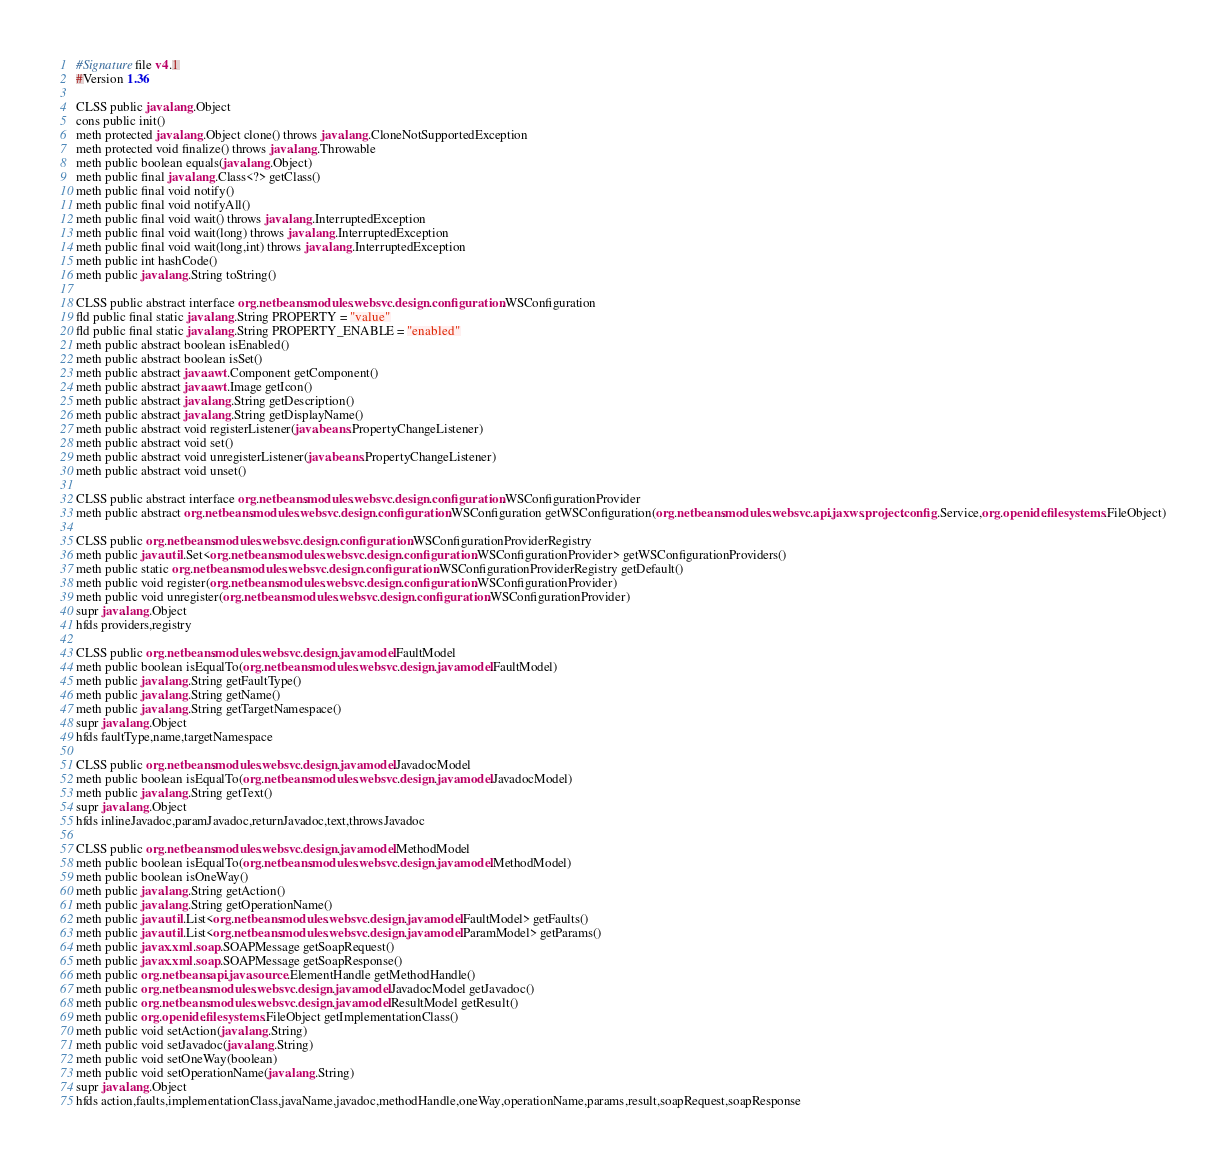Convert code to text. <code><loc_0><loc_0><loc_500><loc_500><_SML_>#Signature file v4.1
#Version 1.36

CLSS public java.lang.Object
cons public init()
meth protected java.lang.Object clone() throws java.lang.CloneNotSupportedException
meth protected void finalize() throws java.lang.Throwable
meth public boolean equals(java.lang.Object)
meth public final java.lang.Class<?> getClass()
meth public final void notify()
meth public final void notifyAll()
meth public final void wait() throws java.lang.InterruptedException
meth public final void wait(long) throws java.lang.InterruptedException
meth public final void wait(long,int) throws java.lang.InterruptedException
meth public int hashCode()
meth public java.lang.String toString()

CLSS public abstract interface org.netbeans.modules.websvc.design.configuration.WSConfiguration
fld public final static java.lang.String PROPERTY = "value"
fld public final static java.lang.String PROPERTY_ENABLE = "enabled"
meth public abstract boolean isEnabled()
meth public abstract boolean isSet()
meth public abstract java.awt.Component getComponent()
meth public abstract java.awt.Image getIcon()
meth public abstract java.lang.String getDescription()
meth public abstract java.lang.String getDisplayName()
meth public abstract void registerListener(java.beans.PropertyChangeListener)
meth public abstract void set()
meth public abstract void unregisterListener(java.beans.PropertyChangeListener)
meth public abstract void unset()

CLSS public abstract interface org.netbeans.modules.websvc.design.configuration.WSConfigurationProvider
meth public abstract org.netbeans.modules.websvc.design.configuration.WSConfiguration getWSConfiguration(org.netbeans.modules.websvc.api.jaxws.project.config.Service,org.openide.filesystems.FileObject)

CLSS public org.netbeans.modules.websvc.design.configuration.WSConfigurationProviderRegistry
meth public java.util.Set<org.netbeans.modules.websvc.design.configuration.WSConfigurationProvider> getWSConfigurationProviders()
meth public static org.netbeans.modules.websvc.design.configuration.WSConfigurationProviderRegistry getDefault()
meth public void register(org.netbeans.modules.websvc.design.configuration.WSConfigurationProvider)
meth public void unregister(org.netbeans.modules.websvc.design.configuration.WSConfigurationProvider)
supr java.lang.Object
hfds providers,registry

CLSS public org.netbeans.modules.websvc.design.javamodel.FaultModel
meth public boolean isEqualTo(org.netbeans.modules.websvc.design.javamodel.FaultModel)
meth public java.lang.String getFaultType()
meth public java.lang.String getName()
meth public java.lang.String getTargetNamespace()
supr java.lang.Object
hfds faultType,name,targetNamespace

CLSS public org.netbeans.modules.websvc.design.javamodel.JavadocModel
meth public boolean isEqualTo(org.netbeans.modules.websvc.design.javamodel.JavadocModel)
meth public java.lang.String getText()
supr java.lang.Object
hfds inlineJavadoc,paramJavadoc,returnJavadoc,text,throwsJavadoc

CLSS public org.netbeans.modules.websvc.design.javamodel.MethodModel
meth public boolean isEqualTo(org.netbeans.modules.websvc.design.javamodel.MethodModel)
meth public boolean isOneWay()
meth public java.lang.String getAction()
meth public java.lang.String getOperationName()
meth public java.util.List<org.netbeans.modules.websvc.design.javamodel.FaultModel> getFaults()
meth public java.util.List<org.netbeans.modules.websvc.design.javamodel.ParamModel> getParams()
meth public javax.xml.soap.SOAPMessage getSoapRequest()
meth public javax.xml.soap.SOAPMessage getSoapResponse()
meth public org.netbeans.api.java.source.ElementHandle getMethodHandle()
meth public org.netbeans.modules.websvc.design.javamodel.JavadocModel getJavadoc()
meth public org.netbeans.modules.websvc.design.javamodel.ResultModel getResult()
meth public org.openide.filesystems.FileObject getImplementationClass()
meth public void setAction(java.lang.String)
meth public void setJavadoc(java.lang.String)
meth public void setOneWay(boolean)
meth public void setOperationName(java.lang.String)
supr java.lang.Object
hfds action,faults,implementationClass,javaName,javadoc,methodHandle,oneWay,operationName,params,result,soapRequest,soapResponse
</code> 